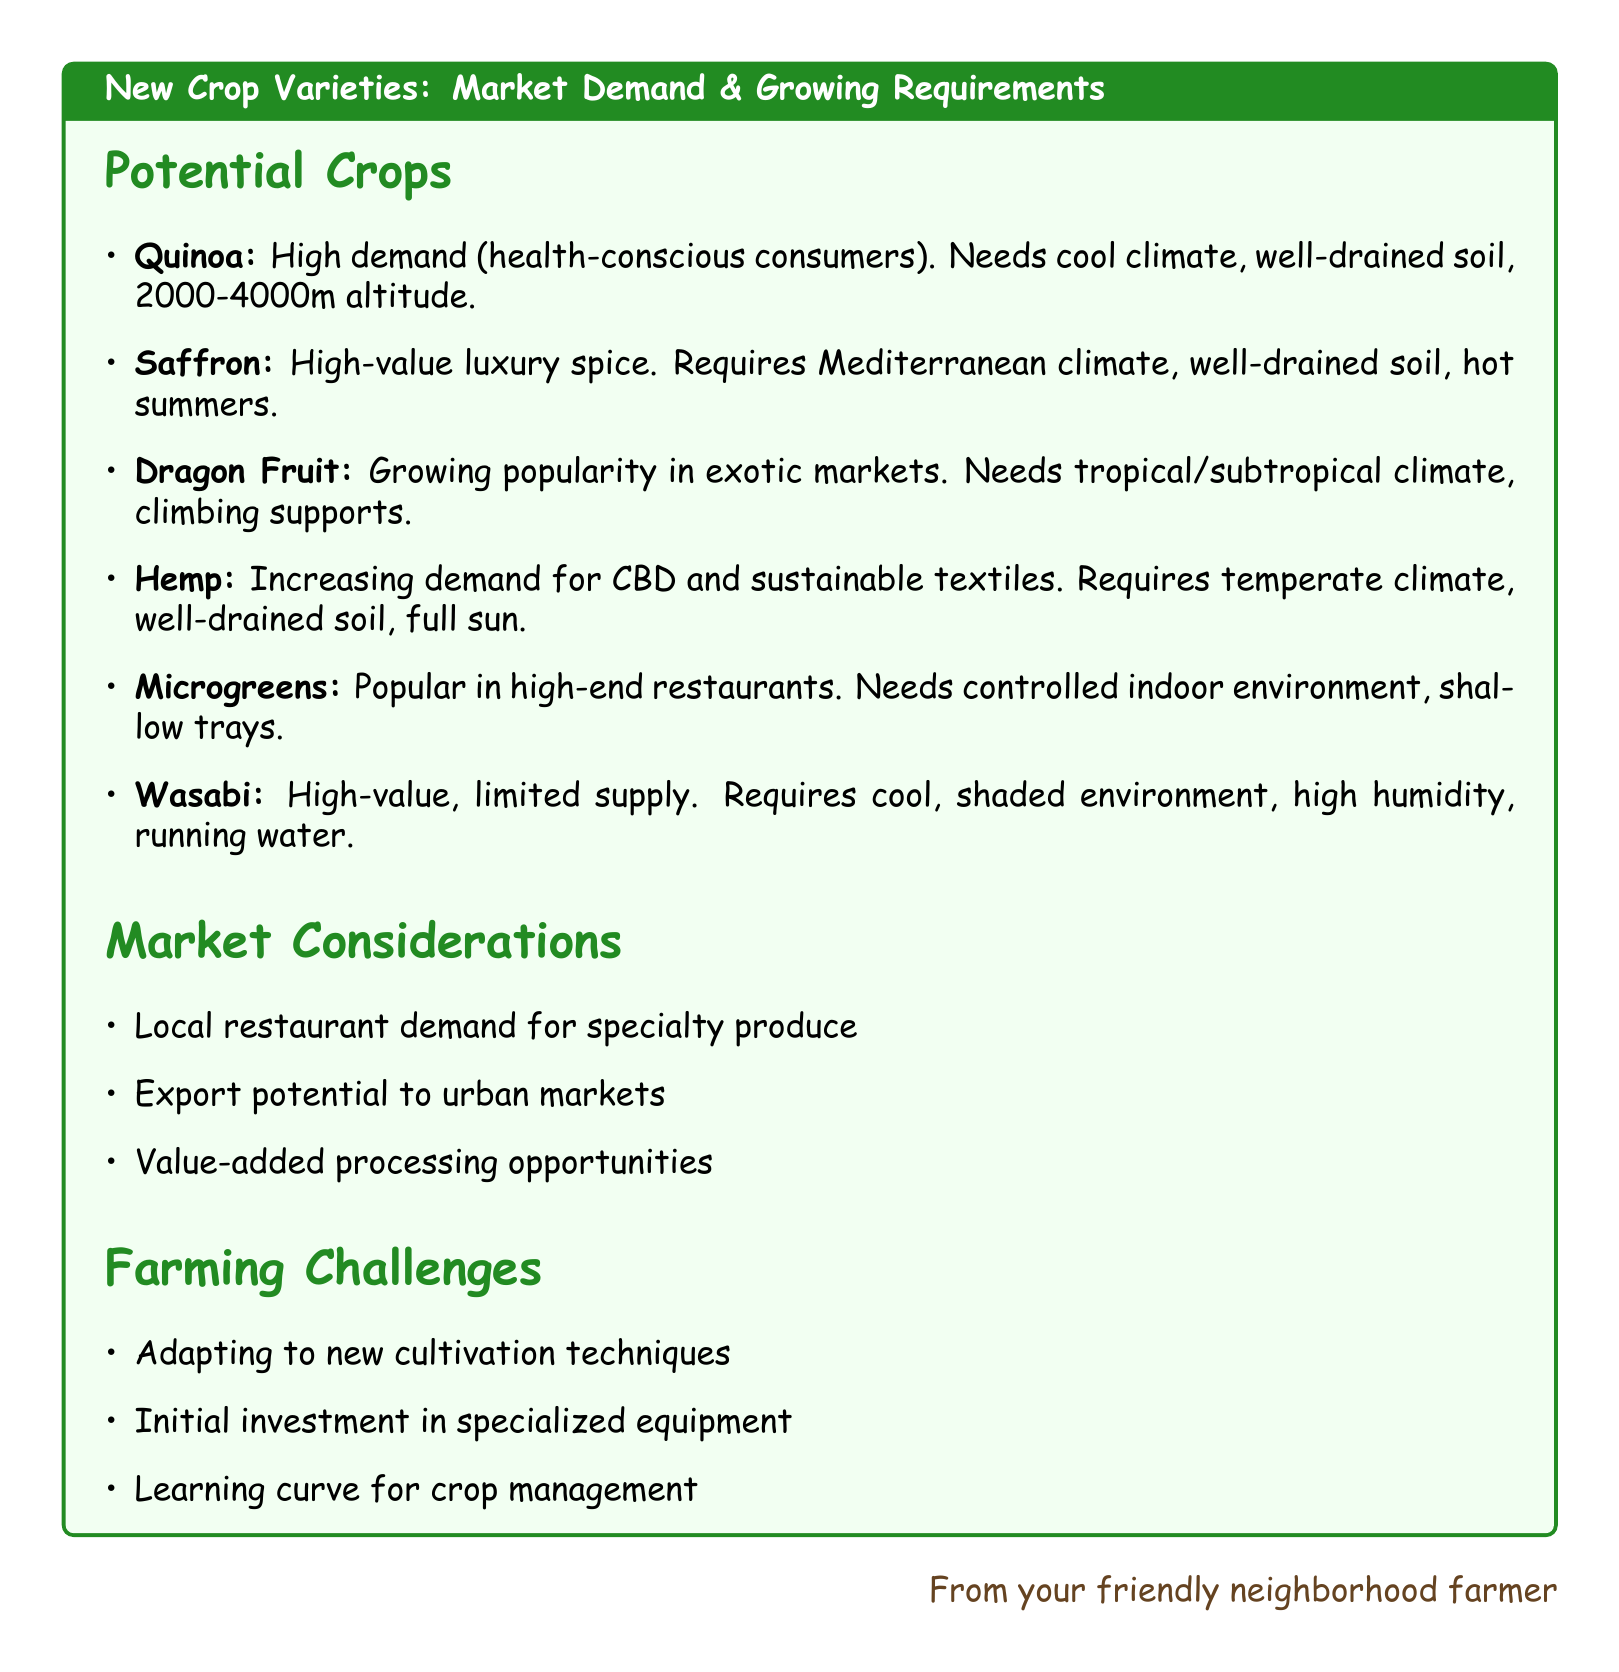What is the market demand for Quinoa? The market demand for Quinoa is categorized as high, primarily due to increasing health-conscious consumers.
Answer: High, due to increasing health-conscious consumers What is required for growing Saffron? Growing Saffron requires a Mediterranean climate, well-drained soil, and hot summers.
Answer: Mediterranean climate, well-drained soil, hot summers What type of climate does Dragon Fruit need? Dragon Fruit needs a tropical or subtropical climate.
Answer: Tropical or subtropical climate What crop has an increasing demand for CBD products? The crop with increasing demand for CBD products is Hemp.
Answer: Hemp Which crop is popular in high-end restaurants? The crop popular in high-end restaurants is Microgreens.
Answer: Microgreens What is one of the farming challenges mentioned? One of the farming challenges mentioned is adapting to new cultivation techniques.
Answer: Adapting to new cultivation techniques What is a potential market consideration for new crops? A potential market consideration for new crops is local restaurant demand for specialty produce.
Answer: Local restaurant demand for specialty produce What altitude is suitable for growing Quinoa? A suitable altitude for growing Quinoa is between 2,000 to 4,000 meters.
Answer: 2000-4000m altitude What is the market demand for Wasabi? The market demand for Wasabi is categorized as high-value with limited global supply.
Answer: High-value crop with limited global supply 